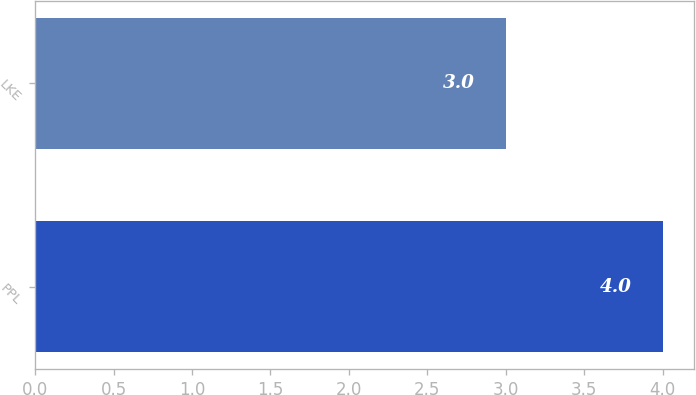<chart> <loc_0><loc_0><loc_500><loc_500><bar_chart><fcel>PPL<fcel>LKE<nl><fcel>4<fcel>3<nl></chart> 